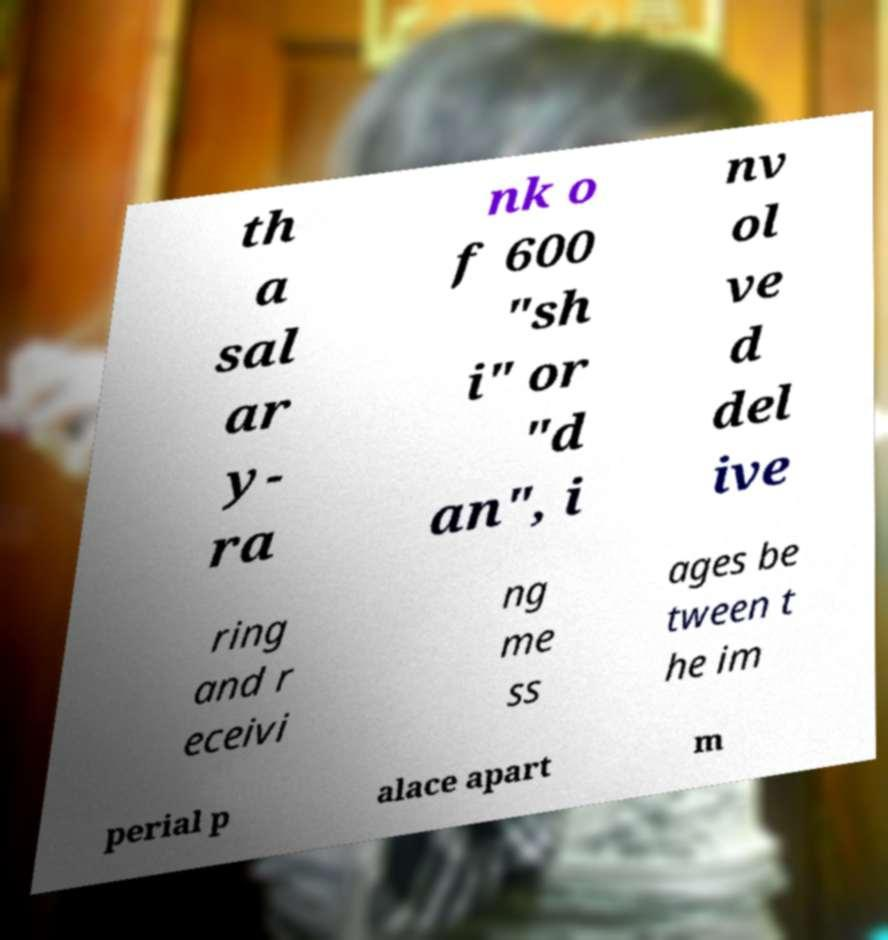Could you assist in decoding the text presented in this image and type it out clearly? th a sal ar y- ra nk o f 600 "sh i" or "d an", i nv ol ve d del ive ring and r eceivi ng me ss ages be tween t he im perial p alace apart m 